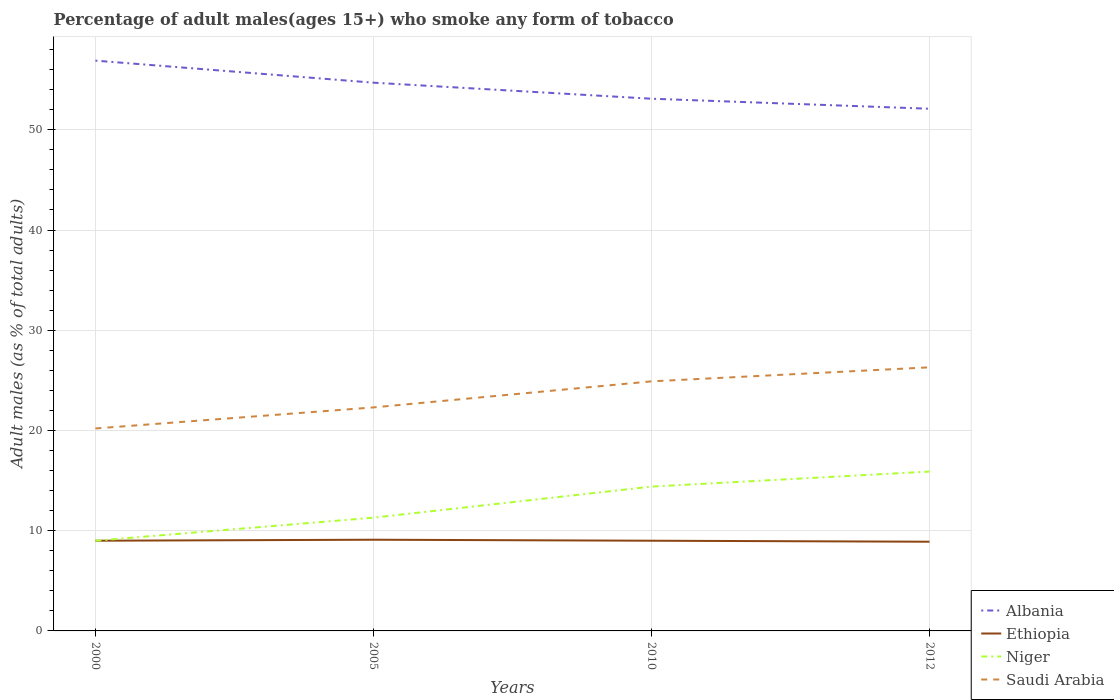How many different coloured lines are there?
Keep it short and to the point. 4. Across all years, what is the maximum percentage of adult males who smoke in Albania?
Provide a succinct answer. 52.1. In which year was the percentage of adult males who smoke in Saudi Arabia maximum?
Offer a terse response. 2000. What is the total percentage of adult males who smoke in Saudi Arabia in the graph?
Your answer should be compact. -4. What is the difference between the highest and the second highest percentage of adult males who smoke in Albania?
Your answer should be compact. 4.8. Where does the legend appear in the graph?
Offer a very short reply. Bottom right. What is the title of the graph?
Make the answer very short. Percentage of adult males(ages 15+) who smoke any form of tobacco. What is the label or title of the Y-axis?
Make the answer very short. Adult males (as % of total adults). What is the Adult males (as % of total adults) in Albania in 2000?
Provide a short and direct response. 56.9. What is the Adult males (as % of total adults) of Ethiopia in 2000?
Offer a very short reply. 9. What is the Adult males (as % of total adults) in Saudi Arabia in 2000?
Offer a terse response. 20.2. What is the Adult males (as % of total adults) in Albania in 2005?
Offer a very short reply. 54.7. What is the Adult males (as % of total adults) of Ethiopia in 2005?
Offer a very short reply. 9.1. What is the Adult males (as % of total adults) of Niger in 2005?
Offer a very short reply. 11.3. What is the Adult males (as % of total adults) of Saudi Arabia in 2005?
Make the answer very short. 22.3. What is the Adult males (as % of total adults) of Albania in 2010?
Offer a terse response. 53.1. What is the Adult males (as % of total adults) of Saudi Arabia in 2010?
Offer a very short reply. 24.9. What is the Adult males (as % of total adults) of Albania in 2012?
Provide a short and direct response. 52.1. What is the Adult males (as % of total adults) in Ethiopia in 2012?
Provide a succinct answer. 8.9. What is the Adult males (as % of total adults) in Saudi Arabia in 2012?
Give a very brief answer. 26.3. Across all years, what is the maximum Adult males (as % of total adults) of Albania?
Your answer should be very brief. 56.9. Across all years, what is the maximum Adult males (as % of total adults) in Niger?
Your response must be concise. 15.9. Across all years, what is the maximum Adult males (as % of total adults) of Saudi Arabia?
Keep it short and to the point. 26.3. Across all years, what is the minimum Adult males (as % of total adults) of Albania?
Your answer should be compact. 52.1. Across all years, what is the minimum Adult males (as % of total adults) of Ethiopia?
Provide a short and direct response. 8.9. Across all years, what is the minimum Adult males (as % of total adults) of Niger?
Offer a very short reply. 9. Across all years, what is the minimum Adult males (as % of total adults) in Saudi Arabia?
Provide a succinct answer. 20.2. What is the total Adult males (as % of total adults) in Albania in the graph?
Your answer should be very brief. 216.8. What is the total Adult males (as % of total adults) in Ethiopia in the graph?
Ensure brevity in your answer.  36. What is the total Adult males (as % of total adults) of Niger in the graph?
Provide a succinct answer. 50.6. What is the total Adult males (as % of total adults) in Saudi Arabia in the graph?
Ensure brevity in your answer.  93.7. What is the difference between the Adult males (as % of total adults) in Albania in 2000 and that in 2005?
Keep it short and to the point. 2.2. What is the difference between the Adult males (as % of total adults) of Ethiopia in 2000 and that in 2005?
Make the answer very short. -0.1. What is the difference between the Adult males (as % of total adults) in Saudi Arabia in 2000 and that in 2005?
Keep it short and to the point. -2.1. What is the difference between the Adult males (as % of total adults) of Albania in 2000 and that in 2010?
Give a very brief answer. 3.8. What is the difference between the Adult males (as % of total adults) in Niger in 2000 and that in 2010?
Your answer should be compact. -5.4. What is the difference between the Adult males (as % of total adults) in Albania in 2000 and that in 2012?
Give a very brief answer. 4.8. What is the difference between the Adult males (as % of total adults) in Niger in 2000 and that in 2012?
Give a very brief answer. -6.9. What is the difference between the Adult males (as % of total adults) of Albania in 2005 and that in 2010?
Your answer should be very brief. 1.6. What is the difference between the Adult males (as % of total adults) in Saudi Arabia in 2005 and that in 2010?
Your answer should be compact. -2.6. What is the difference between the Adult males (as % of total adults) in Ethiopia in 2010 and that in 2012?
Provide a succinct answer. 0.1. What is the difference between the Adult males (as % of total adults) in Saudi Arabia in 2010 and that in 2012?
Your answer should be very brief. -1.4. What is the difference between the Adult males (as % of total adults) in Albania in 2000 and the Adult males (as % of total adults) in Ethiopia in 2005?
Your answer should be very brief. 47.8. What is the difference between the Adult males (as % of total adults) of Albania in 2000 and the Adult males (as % of total adults) of Niger in 2005?
Keep it short and to the point. 45.6. What is the difference between the Adult males (as % of total adults) of Albania in 2000 and the Adult males (as % of total adults) of Saudi Arabia in 2005?
Offer a very short reply. 34.6. What is the difference between the Adult males (as % of total adults) of Albania in 2000 and the Adult males (as % of total adults) of Ethiopia in 2010?
Your response must be concise. 47.9. What is the difference between the Adult males (as % of total adults) in Albania in 2000 and the Adult males (as % of total adults) in Niger in 2010?
Your answer should be very brief. 42.5. What is the difference between the Adult males (as % of total adults) of Albania in 2000 and the Adult males (as % of total adults) of Saudi Arabia in 2010?
Offer a terse response. 32. What is the difference between the Adult males (as % of total adults) in Ethiopia in 2000 and the Adult males (as % of total adults) in Saudi Arabia in 2010?
Ensure brevity in your answer.  -15.9. What is the difference between the Adult males (as % of total adults) in Niger in 2000 and the Adult males (as % of total adults) in Saudi Arabia in 2010?
Provide a short and direct response. -15.9. What is the difference between the Adult males (as % of total adults) of Albania in 2000 and the Adult males (as % of total adults) of Ethiopia in 2012?
Your response must be concise. 48. What is the difference between the Adult males (as % of total adults) in Albania in 2000 and the Adult males (as % of total adults) in Niger in 2012?
Your answer should be very brief. 41. What is the difference between the Adult males (as % of total adults) in Albania in 2000 and the Adult males (as % of total adults) in Saudi Arabia in 2012?
Offer a terse response. 30.6. What is the difference between the Adult males (as % of total adults) in Ethiopia in 2000 and the Adult males (as % of total adults) in Niger in 2012?
Provide a short and direct response. -6.9. What is the difference between the Adult males (as % of total adults) in Ethiopia in 2000 and the Adult males (as % of total adults) in Saudi Arabia in 2012?
Keep it short and to the point. -17.3. What is the difference between the Adult males (as % of total adults) of Niger in 2000 and the Adult males (as % of total adults) of Saudi Arabia in 2012?
Your answer should be compact. -17.3. What is the difference between the Adult males (as % of total adults) in Albania in 2005 and the Adult males (as % of total adults) in Ethiopia in 2010?
Ensure brevity in your answer.  45.7. What is the difference between the Adult males (as % of total adults) in Albania in 2005 and the Adult males (as % of total adults) in Niger in 2010?
Give a very brief answer. 40.3. What is the difference between the Adult males (as % of total adults) of Albania in 2005 and the Adult males (as % of total adults) of Saudi Arabia in 2010?
Provide a succinct answer. 29.8. What is the difference between the Adult males (as % of total adults) in Ethiopia in 2005 and the Adult males (as % of total adults) in Niger in 2010?
Give a very brief answer. -5.3. What is the difference between the Adult males (as % of total adults) in Ethiopia in 2005 and the Adult males (as % of total adults) in Saudi Arabia in 2010?
Make the answer very short. -15.8. What is the difference between the Adult males (as % of total adults) of Albania in 2005 and the Adult males (as % of total adults) of Ethiopia in 2012?
Your answer should be compact. 45.8. What is the difference between the Adult males (as % of total adults) in Albania in 2005 and the Adult males (as % of total adults) in Niger in 2012?
Your answer should be compact. 38.8. What is the difference between the Adult males (as % of total adults) in Albania in 2005 and the Adult males (as % of total adults) in Saudi Arabia in 2012?
Your answer should be very brief. 28.4. What is the difference between the Adult males (as % of total adults) in Ethiopia in 2005 and the Adult males (as % of total adults) in Saudi Arabia in 2012?
Ensure brevity in your answer.  -17.2. What is the difference between the Adult males (as % of total adults) in Albania in 2010 and the Adult males (as % of total adults) in Ethiopia in 2012?
Your response must be concise. 44.2. What is the difference between the Adult males (as % of total adults) of Albania in 2010 and the Adult males (as % of total adults) of Niger in 2012?
Your answer should be very brief. 37.2. What is the difference between the Adult males (as % of total adults) in Albania in 2010 and the Adult males (as % of total adults) in Saudi Arabia in 2012?
Your answer should be very brief. 26.8. What is the difference between the Adult males (as % of total adults) of Ethiopia in 2010 and the Adult males (as % of total adults) of Saudi Arabia in 2012?
Ensure brevity in your answer.  -17.3. What is the average Adult males (as % of total adults) of Albania per year?
Your response must be concise. 54.2. What is the average Adult males (as % of total adults) in Ethiopia per year?
Your answer should be compact. 9. What is the average Adult males (as % of total adults) of Niger per year?
Your answer should be very brief. 12.65. What is the average Adult males (as % of total adults) in Saudi Arabia per year?
Provide a succinct answer. 23.43. In the year 2000, what is the difference between the Adult males (as % of total adults) in Albania and Adult males (as % of total adults) in Ethiopia?
Your answer should be very brief. 47.9. In the year 2000, what is the difference between the Adult males (as % of total adults) in Albania and Adult males (as % of total adults) in Niger?
Your response must be concise. 47.9. In the year 2000, what is the difference between the Adult males (as % of total adults) of Albania and Adult males (as % of total adults) of Saudi Arabia?
Offer a very short reply. 36.7. In the year 2000, what is the difference between the Adult males (as % of total adults) in Ethiopia and Adult males (as % of total adults) in Saudi Arabia?
Provide a succinct answer. -11.2. In the year 2005, what is the difference between the Adult males (as % of total adults) of Albania and Adult males (as % of total adults) of Ethiopia?
Provide a short and direct response. 45.6. In the year 2005, what is the difference between the Adult males (as % of total adults) of Albania and Adult males (as % of total adults) of Niger?
Give a very brief answer. 43.4. In the year 2005, what is the difference between the Adult males (as % of total adults) in Albania and Adult males (as % of total adults) in Saudi Arabia?
Your response must be concise. 32.4. In the year 2005, what is the difference between the Adult males (as % of total adults) of Ethiopia and Adult males (as % of total adults) of Saudi Arabia?
Provide a succinct answer. -13.2. In the year 2010, what is the difference between the Adult males (as % of total adults) in Albania and Adult males (as % of total adults) in Ethiopia?
Keep it short and to the point. 44.1. In the year 2010, what is the difference between the Adult males (as % of total adults) in Albania and Adult males (as % of total adults) in Niger?
Keep it short and to the point. 38.7. In the year 2010, what is the difference between the Adult males (as % of total adults) in Albania and Adult males (as % of total adults) in Saudi Arabia?
Give a very brief answer. 28.2. In the year 2010, what is the difference between the Adult males (as % of total adults) of Ethiopia and Adult males (as % of total adults) of Saudi Arabia?
Provide a short and direct response. -15.9. In the year 2010, what is the difference between the Adult males (as % of total adults) of Niger and Adult males (as % of total adults) of Saudi Arabia?
Your response must be concise. -10.5. In the year 2012, what is the difference between the Adult males (as % of total adults) in Albania and Adult males (as % of total adults) in Ethiopia?
Your answer should be compact. 43.2. In the year 2012, what is the difference between the Adult males (as % of total adults) of Albania and Adult males (as % of total adults) of Niger?
Provide a succinct answer. 36.2. In the year 2012, what is the difference between the Adult males (as % of total adults) of Albania and Adult males (as % of total adults) of Saudi Arabia?
Provide a succinct answer. 25.8. In the year 2012, what is the difference between the Adult males (as % of total adults) of Ethiopia and Adult males (as % of total adults) of Niger?
Your answer should be compact. -7. In the year 2012, what is the difference between the Adult males (as % of total adults) in Ethiopia and Adult males (as % of total adults) in Saudi Arabia?
Provide a short and direct response. -17.4. In the year 2012, what is the difference between the Adult males (as % of total adults) in Niger and Adult males (as % of total adults) in Saudi Arabia?
Ensure brevity in your answer.  -10.4. What is the ratio of the Adult males (as % of total adults) in Albania in 2000 to that in 2005?
Your response must be concise. 1.04. What is the ratio of the Adult males (as % of total adults) in Niger in 2000 to that in 2005?
Offer a terse response. 0.8. What is the ratio of the Adult males (as % of total adults) in Saudi Arabia in 2000 to that in 2005?
Your answer should be very brief. 0.91. What is the ratio of the Adult males (as % of total adults) in Albania in 2000 to that in 2010?
Make the answer very short. 1.07. What is the ratio of the Adult males (as % of total adults) of Niger in 2000 to that in 2010?
Give a very brief answer. 0.62. What is the ratio of the Adult males (as % of total adults) of Saudi Arabia in 2000 to that in 2010?
Give a very brief answer. 0.81. What is the ratio of the Adult males (as % of total adults) in Albania in 2000 to that in 2012?
Your answer should be compact. 1.09. What is the ratio of the Adult males (as % of total adults) in Ethiopia in 2000 to that in 2012?
Make the answer very short. 1.01. What is the ratio of the Adult males (as % of total adults) of Niger in 2000 to that in 2012?
Your answer should be very brief. 0.57. What is the ratio of the Adult males (as % of total adults) of Saudi Arabia in 2000 to that in 2012?
Offer a terse response. 0.77. What is the ratio of the Adult males (as % of total adults) in Albania in 2005 to that in 2010?
Offer a very short reply. 1.03. What is the ratio of the Adult males (as % of total adults) in Ethiopia in 2005 to that in 2010?
Your response must be concise. 1.01. What is the ratio of the Adult males (as % of total adults) in Niger in 2005 to that in 2010?
Your answer should be compact. 0.78. What is the ratio of the Adult males (as % of total adults) of Saudi Arabia in 2005 to that in 2010?
Provide a succinct answer. 0.9. What is the ratio of the Adult males (as % of total adults) in Albania in 2005 to that in 2012?
Provide a short and direct response. 1.05. What is the ratio of the Adult males (as % of total adults) of Ethiopia in 2005 to that in 2012?
Provide a short and direct response. 1.02. What is the ratio of the Adult males (as % of total adults) in Niger in 2005 to that in 2012?
Keep it short and to the point. 0.71. What is the ratio of the Adult males (as % of total adults) of Saudi Arabia in 2005 to that in 2012?
Offer a terse response. 0.85. What is the ratio of the Adult males (as % of total adults) in Albania in 2010 to that in 2012?
Provide a succinct answer. 1.02. What is the ratio of the Adult males (as % of total adults) in Ethiopia in 2010 to that in 2012?
Provide a short and direct response. 1.01. What is the ratio of the Adult males (as % of total adults) of Niger in 2010 to that in 2012?
Make the answer very short. 0.91. What is the ratio of the Adult males (as % of total adults) of Saudi Arabia in 2010 to that in 2012?
Your answer should be very brief. 0.95. What is the difference between the highest and the second highest Adult males (as % of total adults) of Albania?
Keep it short and to the point. 2.2. What is the difference between the highest and the second highest Adult males (as % of total adults) in Ethiopia?
Make the answer very short. 0.1. What is the difference between the highest and the second highest Adult males (as % of total adults) of Niger?
Offer a very short reply. 1.5. What is the difference between the highest and the lowest Adult males (as % of total adults) of Albania?
Give a very brief answer. 4.8. What is the difference between the highest and the lowest Adult males (as % of total adults) in Ethiopia?
Provide a succinct answer. 0.2. What is the difference between the highest and the lowest Adult males (as % of total adults) of Niger?
Your answer should be compact. 6.9. 